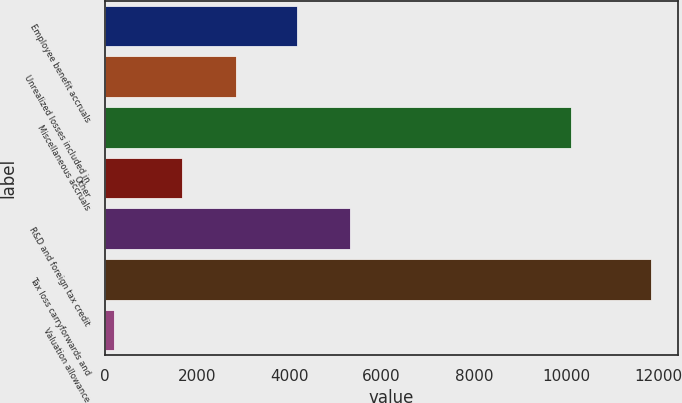Convert chart. <chart><loc_0><loc_0><loc_500><loc_500><bar_chart><fcel>Employee benefit accruals<fcel>Unrealized losses included in<fcel>Miscellaneous accruals<fcel>Other<fcel>R&D and foreign tax credit<fcel>Tax loss carryforwards and<fcel>Valuation allowance<nl><fcel>4159<fcel>2836.9<fcel>10108<fcel>1673<fcel>5322.9<fcel>11833<fcel>194<nl></chart> 